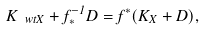<formula> <loc_0><loc_0><loc_500><loc_500>K _ { \ w t { X } } + f _ { * } ^ { - 1 } D = f ^ { * } ( K _ { X } + D ) ,</formula> 